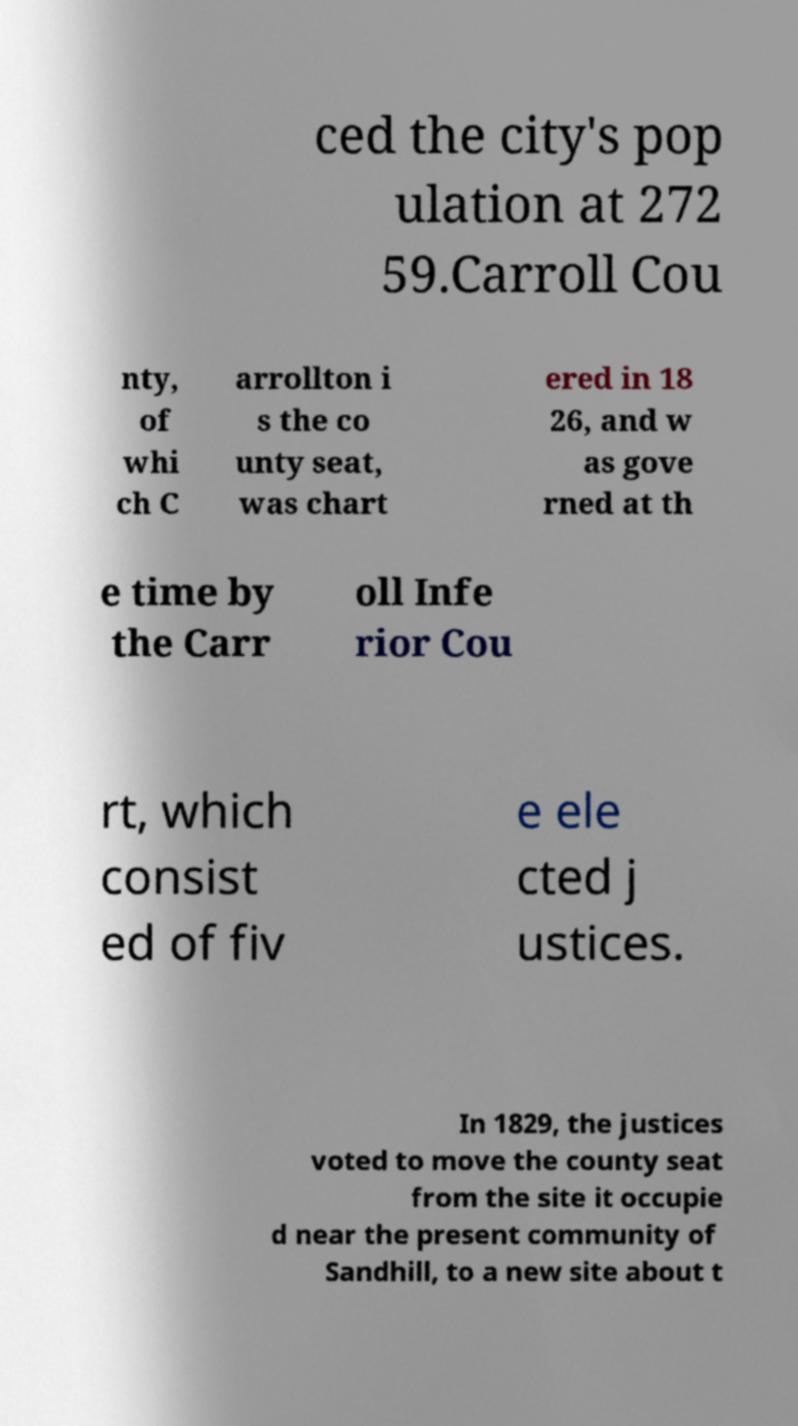Please read and relay the text visible in this image. What does it say? ced the city's pop ulation at 272 59.Carroll Cou nty, of whi ch C arrollton i s the co unty seat, was chart ered in 18 26, and w as gove rned at th e time by the Carr oll Infe rior Cou rt, which consist ed of fiv e ele cted j ustices. In 1829, the justices voted to move the county seat from the site it occupie d near the present community of Sandhill, to a new site about t 